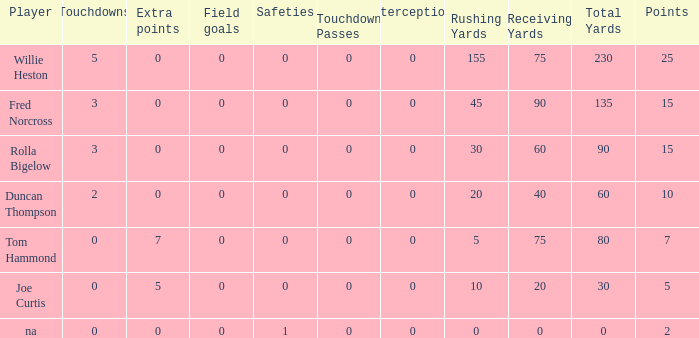How many Touchdowns have a Player of rolla bigelow, and an Extra points smaller than 0? None. 